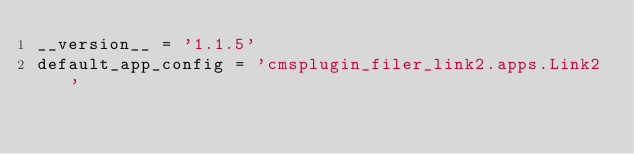<code> <loc_0><loc_0><loc_500><loc_500><_Python_>__version__ = '1.1.5'
default_app_config = 'cmsplugin_filer_link2.apps.Link2'
</code> 